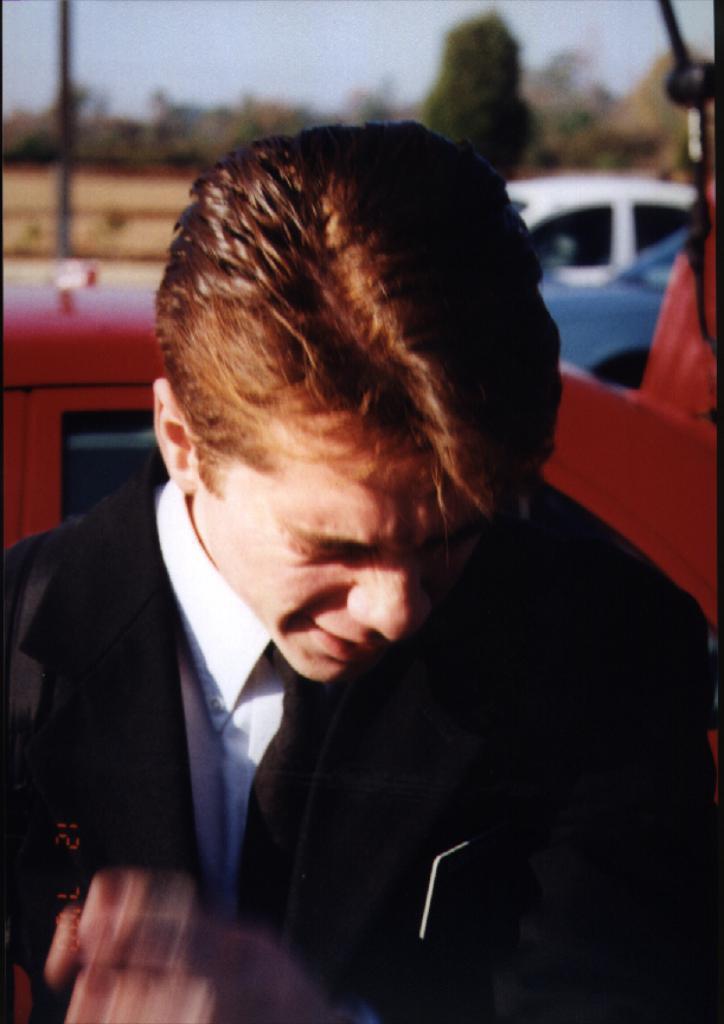Can you describe this image briefly? In the picture we can see a man bowing his head down and he is with a black color blazer and white shirt and behind him we can see a car which is red in color and behind it also we can see two cars and behind it we can see a pole and some trees and sky. 